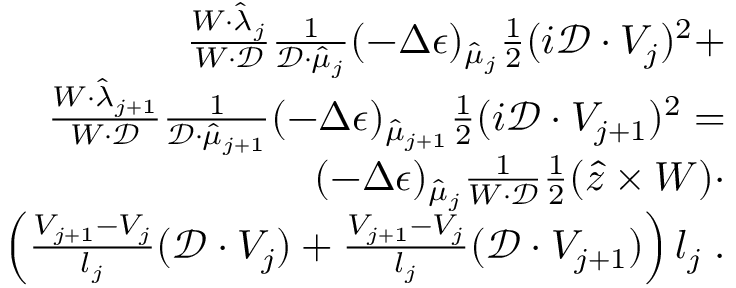<formula> <loc_0><loc_0><loc_500><loc_500>\begin{array} { r l } { \frac { W \cdot \hat { \lambda } _ { j } } { W \cdot \mathcal { D } } \frac { 1 } { \mathcal { D } \cdot \hat { \mu } _ { j } } ( - \Delta \epsilon ) _ { \hat { \mu } _ { j } } \frac { 1 } { 2 } ( i \mathcal { D } \cdot V _ { j } ) ^ { 2 } + } \\ { \frac { W \cdot \hat { \lambda } _ { j + 1 } } { W \cdot \mathcal { D } } \frac { 1 } { \mathcal { D } \cdot \hat { \mu } _ { j + 1 } } ( - \Delta \epsilon ) _ { \hat { \mu } _ { j + 1 } } \frac { 1 } { 2 } ( i \mathcal { D } \cdot V _ { j + 1 } ) ^ { 2 } = } \\ { ( - \Delta \epsilon ) _ { \hat { \mu } _ { j } } \frac { 1 } { W \cdot \mathcal { D } } \frac { 1 } { 2 } ( \hat { z } \times W ) \cdot } \\ { \left ( \frac { V _ { j + 1 } - V _ { j } } { l _ { j } } ( \mathcal { D } \cdot V _ { j } ) + \frac { V _ { j + 1 } - V _ { j } } { l _ { j } } ( \mathcal { D } \cdot V _ { j + 1 } ) \right ) l _ { j } \, . } \end{array}</formula> 